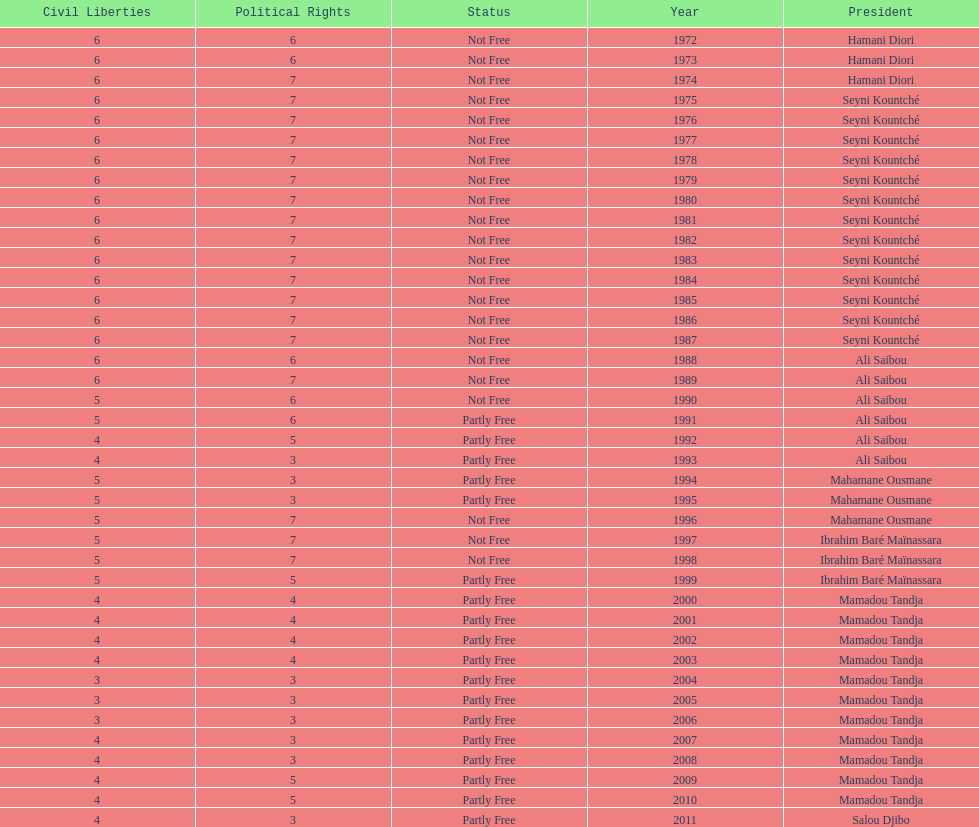Who ruled longer, ali saibou or mamadou tandja? Mamadou Tandja. 